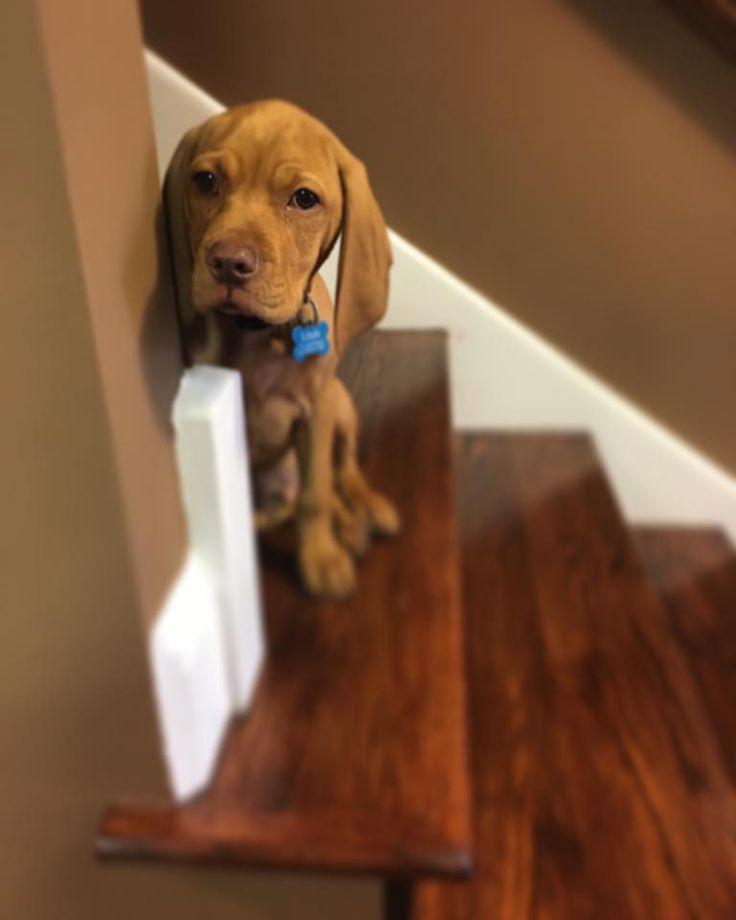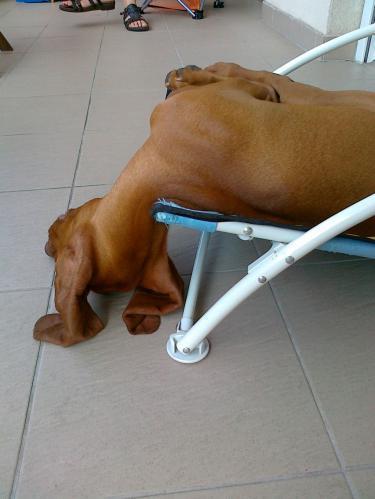The first image is the image on the left, the second image is the image on the right. Examine the images to the left and right. Is the description "The dog in the image on the left is sitting on a wooden surface." accurate? Answer yes or no. Yes. 